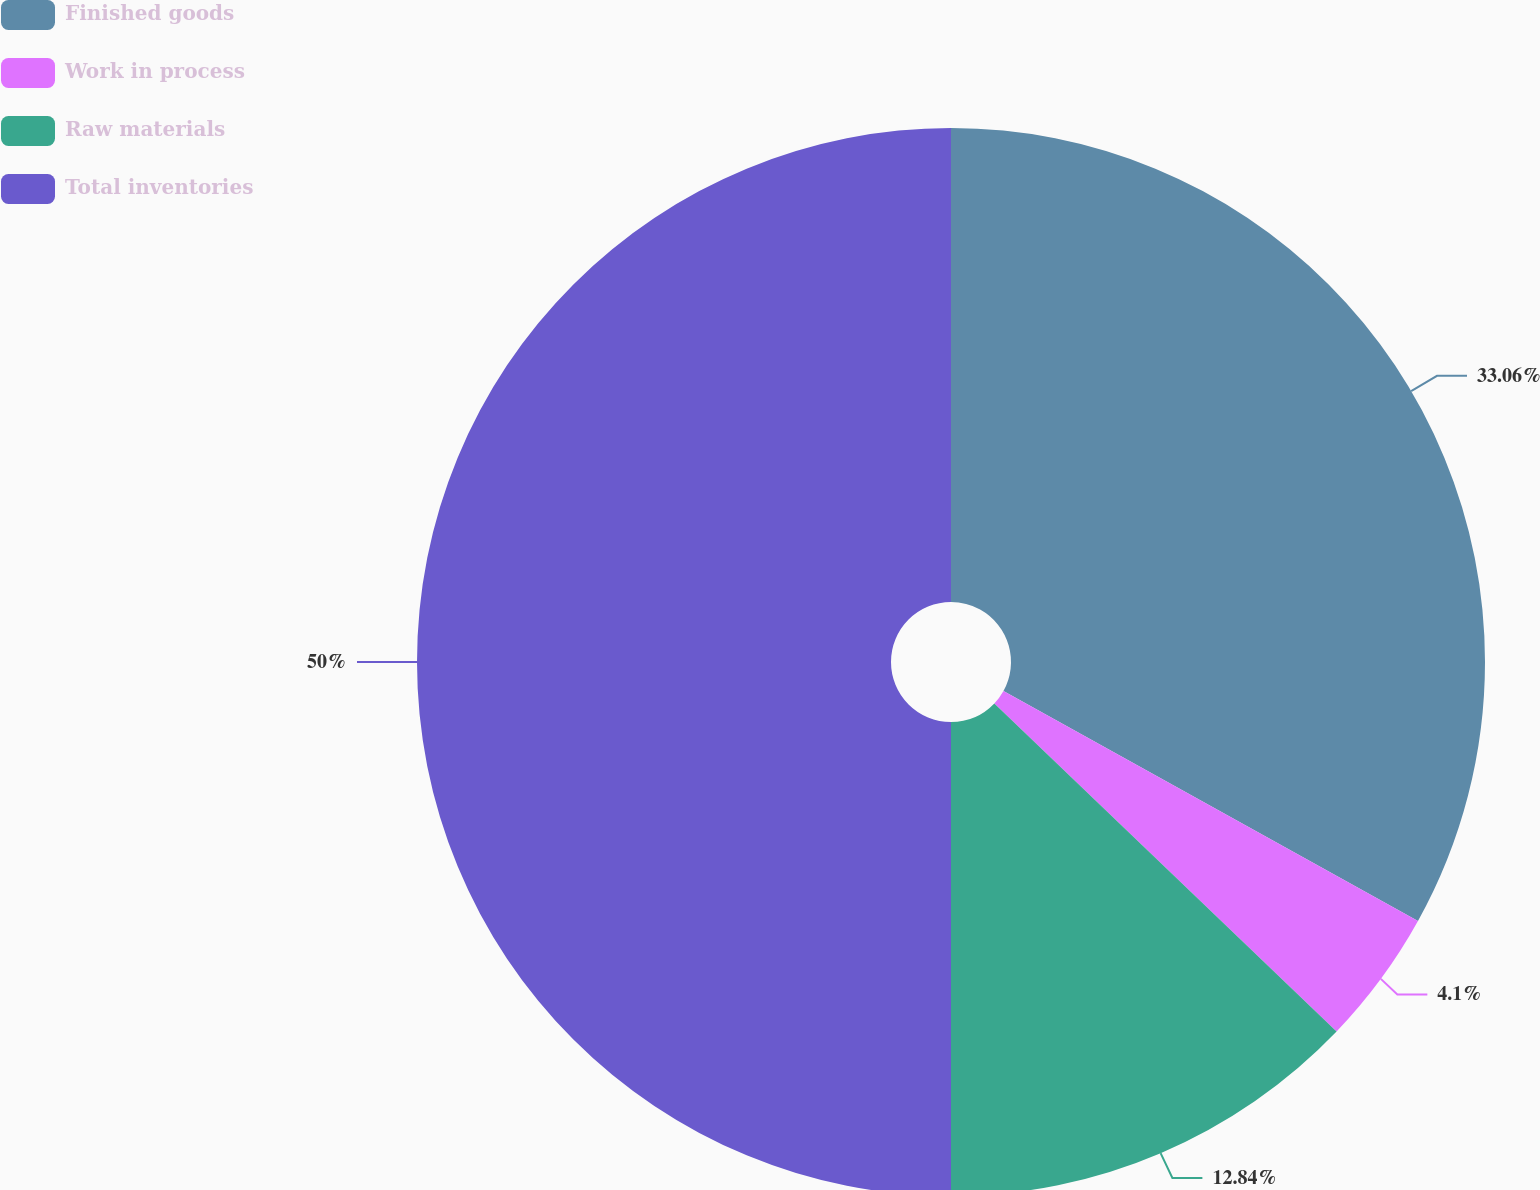Convert chart to OTSL. <chart><loc_0><loc_0><loc_500><loc_500><pie_chart><fcel>Finished goods<fcel>Work in process<fcel>Raw materials<fcel>Total inventories<nl><fcel>33.06%<fcel>4.1%<fcel>12.84%<fcel>50.0%<nl></chart> 